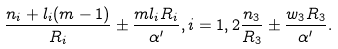<formula> <loc_0><loc_0><loc_500><loc_500>\frac { n _ { i } + l _ { i } ( m - 1 ) } { R _ { i } } \pm \frac { m l _ { i } R _ { i } } { \alpha ^ { \prime } } , i = 1 , 2 \frac { n _ { 3 } } { R _ { 3 } } \pm \frac { w _ { 3 } R _ { 3 } } { \alpha ^ { \prime } } .</formula> 